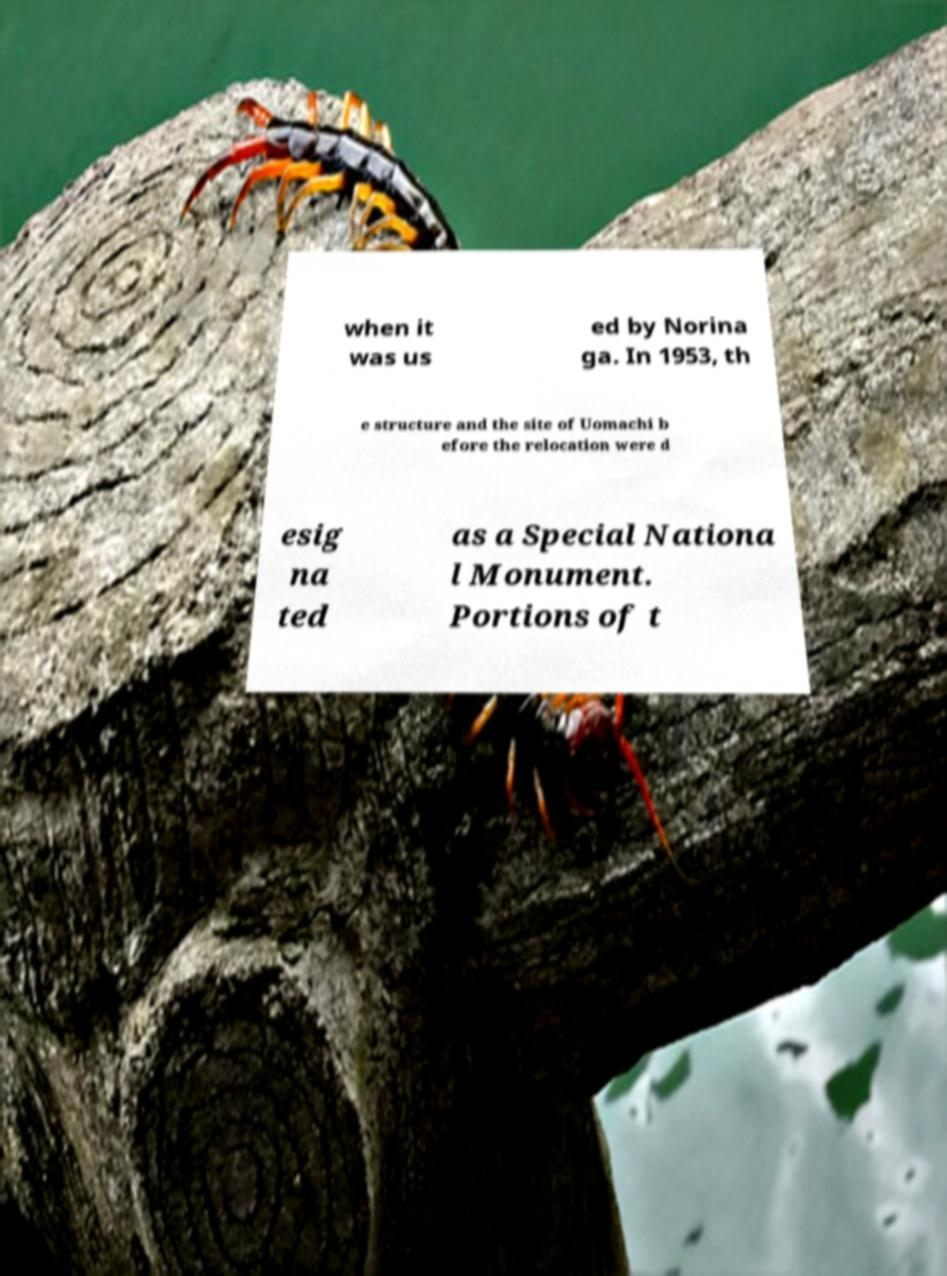Please identify and transcribe the text found in this image. when it was us ed by Norina ga. In 1953, th e structure and the site of Uomachi b efore the relocation were d esig na ted as a Special Nationa l Monument. Portions of t 